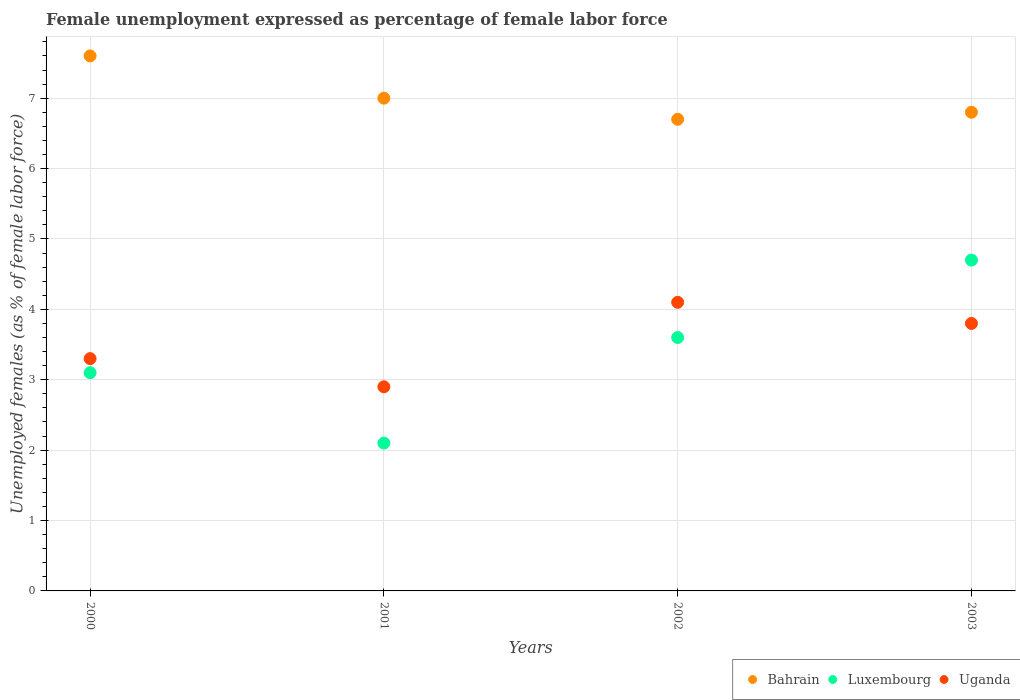Is the number of dotlines equal to the number of legend labels?
Your response must be concise. Yes. What is the unemployment in females in in Uganda in 2002?
Your response must be concise. 4.1. Across all years, what is the maximum unemployment in females in in Bahrain?
Make the answer very short. 7.6. Across all years, what is the minimum unemployment in females in in Bahrain?
Your answer should be very brief. 6.7. In which year was the unemployment in females in in Bahrain minimum?
Provide a succinct answer. 2002. What is the total unemployment in females in in Bahrain in the graph?
Give a very brief answer. 28.1. What is the difference between the unemployment in females in in Bahrain in 2000 and that in 2001?
Make the answer very short. 0.6. What is the difference between the unemployment in females in in Bahrain in 2003 and the unemployment in females in in Luxembourg in 2001?
Your answer should be very brief. 4.7. What is the average unemployment in females in in Bahrain per year?
Make the answer very short. 7.02. In the year 2000, what is the difference between the unemployment in females in in Bahrain and unemployment in females in in Uganda?
Provide a short and direct response. 4.3. In how many years, is the unemployment in females in in Bahrain greater than 0.6000000000000001 %?
Provide a short and direct response. 4. What is the ratio of the unemployment in females in in Bahrain in 2000 to that in 2003?
Your response must be concise. 1.12. Is the unemployment in females in in Bahrain in 2000 less than that in 2002?
Offer a terse response. No. What is the difference between the highest and the second highest unemployment in females in in Bahrain?
Your answer should be very brief. 0.6. What is the difference between the highest and the lowest unemployment in females in in Luxembourg?
Your response must be concise. 2.6. In how many years, is the unemployment in females in in Uganda greater than the average unemployment in females in in Uganda taken over all years?
Your response must be concise. 2. Is the sum of the unemployment in females in in Luxembourg in 2000 and 2001 greater than the maximum unemployment in females in in Bahrain across all years?
Your response must be concise. No. Is it the case that in every year, the sum of the unemployment in females in in Uganda and unemployment in females in in Luxembourg  is greater than the unemployment in females in in Bahrain?
Your answer should be very brief. No. Does the unemployment in females in in Luxembourg monotonically increase over the years?
Offer a very short reply. No. Is the unemployment in females in in Bahrain strictly greater than the unemployment in females in in Uganda over the years?
Make the answer very short. Yes. Is the unemployment in females in in Uganda strictly less than the unemployment in females in in Luxembourg over the years?
Your response must be concise. No. How many dotlines are there?
Provide a succinct answer. 3. What is the difference between two consecutive major ticks on the Y-axis?
Your answer should be very brief. 1. Does the graph contain any zero values?
Your answer should be compact. No. Does the graph contain grids?
Give a very brief answer. Yes. Where does the legend appear in the graph?
Keep it short and to the point. Bottom right. How many legend labels are there?
Your answer should be very brief. 3. What is the title of the graph?
Offer a very short reply. Female unemployment expressed as percentage of female labor force. What is the label or title of the X-axis?
Provide a short and direct response. Years. What is the label or title of the Y-axis?
Offer a very short reply. Unemployed females (as % of female labor force). What is the Unemployed females (as % of female labor force) in Bahrain in 2000?
Keep it short and to the point. 7.6. What is the Unemployed females (as % of female labor force) in Luxembourg in 2000?
Offer a terse response. 3.1. What is the Unemployed females (as % of female labor force) of Uganda in 2000?
Your response must be concise. 3.3. What is the Unemployed females (as % of female labor force) in Luxembourg in 2001?
Provide a short and direct response. 2.1. What is the Unemployed females (as % of female labor force) of Uganda in 2001?
Keep it short and to the point. 2.9. What is the Unemployed females (as % of female labor force) in Bahrain in 2002?
Your answer should be compact. 6.7. What is the Unemployed females (as % of female labor force) in Luxembourg in 2002?
Keep it short and to the point. 3.6. What is the Unemployed females (as % of female labor force) of Uganda in 2002?
Provide a short and direct response. 4.1. What is the Unemployed females (as % of female labor force) of Bahrain in 2003?
Your response must be concise. 6.8. What is the Unemployed females (as % of female labor force) in Luxembourg in 2003?
Offer a terse response. 4.7. What is the Unemployed females (as % of female labor force) in Uganda in 2003?
Provide a succinct answer. 3.8. Across all years, what is the maximum Unemployed females (as % of female labor force) in Bahrain?
Offer a terse response. 7.6. Across all years, what is the maximum Unemployed females (as % of female labor force) in Luxembourg?
Provide a succinct answer. 4.7. Across all years, what is the maximum Unemployed females (as % of female labor force) in Uganda?
Make the answer very short. 4.1. Across all years, what is the minimum Unemployed females (as % of female labor force) of Bahrain?
Keep it short and to the point. 6.7. Across all years, what is the minimum Unemployed females (as % of female labor force) in Luxembourg?
Keep it short and to the point. 2.1. Across all years, what is the minimum Unemployed females (as % of female labor force) in Uganda?
Offer a terse response. 2.9. What is the total Unemployed females (as % of female labor force) of Bahrain in the graph?
Give a very brief answer. 28.1. What is the difference between the Unemployed females (as % of female labor force) in Bahrain in 2000 and that in 2001?
Your answer should be compact. 0.6. What is the difference between the Unemployed females (as % of female labor force) in Uganda in 2000 and that in 2001?
Provide a succinct answer. 0.4. What is the difference between the Unemployed females (as % of female labor force) in Uganda in 2000 and that in 2002?
Provide a short and direct response. -0.8. What is the difference between the Unemployed females (as % of female labor force) of Luxembourg in 2000 and that in 2003?
Provide a short and direct response. -1.6. What is the difference between the Unemployed females (as % of female labor force) in Uganda in 2000 and that in 2003?
Provide a short and direct response. -0.5. What is the difference between the Unemployed females (as % of female labor force) in Bahrain in 2001 and that in 2002?
Your answer should be very brief. 0.3. What is the difference between the Unemployed females (as % of female labor force) in Luxembourg in 2001 and that in 2003?
Offer a very short reply. -2.6. What is the difference between the Unemployed females (as % of female labor force) in Uganda in 2001 and that in 2003?
Your answer should be very brief. -0.9. What is the difference between the Unemployed females (as % of female labor force) in Bahrain in 2002 and that in 2003?
Ensure brevity in your answer.  -0.1. What is the difference between the Unemployed females (as % of female labor force) in Luxembourg in 2002 and that in 2003?
Offer a very short reply. -1.1. What is the difference between the Unemployed females (as % of female labor force) in Uganda in 2002 and that in 2003?
Provide a short and direct response. 0.3. What is the difference between the Unemployed females (as % of female labor force) of Bahrain in 2000 and the Unemployed females (as % of female labor force) of Luxembourg in 2001?
Make the answer very short. 5.5. What is the difference between the Unemployed females (as % of female labor force) of Bahrain in 2000 and the Unemployed females (as % of female labor force) of Uganda in 2001?
Provide a succinct answer. 4.7. What is the difference between the Unemployed females (as % of female labor force) in Luxembourg in 2000 and the Unemployed females (as % of female labor force) in Uganda in 2001?
Your answer should be compact. 0.2. What is the difference between the Unemployed females (as % of female labor force) in Bahrain in 2000 and the Unemployed females (as % of female labor force) in Luxembourg in 2002?
Ensure brevity in your answer.  4. What is the difference between the Unemployed females (as % of female labor force) in Luxembourg in 2000 and the Unemployed females (as % of female labor force) in Uganda in 2002?
Make the answer very short. -1. What is the difference between the Unemployed females (as % of female labor force) in Bahrain in 2000 and the Unemployed females (as % of female labor force) in Uganda in 2003?
Keep it short and to the point. 3.8. What is the difference between the Unemployed females (as % of female labor force) of Luxembourg in 2000 and the Unemployed females (as % of female labor force) of Uganda in 2003?
Make the answer very short. -0.7. What is the difference between the Unemployed females (as % of female labor force) of Luxembourg in 2001 and the Unemployed females (as % of female labor force) of Uganda in 2002?
Make the answer very short. -2. What is the difference between the Unemployed females (as % of female labor force) of Luxembourg in 2001 and the Unemployed females (as % of female labor force) of Uganda in 2003?
Your answer should be very brief. -1.7. What is the difference between the Unemployed females (as % of female labor force) of Luxembourg in 2002 and the Unemployed females (as % of female labor force) of Uganda in 2003?
Your answer should be compact. -0.2. What is the average Unemployed females (as % of female labor force) in Bahrain per year?
Provide a succinct answer. 7.03. What is the average Unemployed females (as % of female labor force) in Luxembourg per year?
Your answer should be compact. 3.38. What is the average Unemployed females (as % of female labor force) in Uganda per year?
Provide a short and direct response. 3.52. In the year 2000, what is the difference between the Unemployed females (as % of female labor force) of Bahrain and Unemployed females (as % of female labor force) of Luxembourg?
Keep it short and to the point. 4.5. In the year 2000, what is the difference between the Unemployed females (as % of female labor force) in Bahrain and Unemployed females (as % of female labor force) in Uganda?
Give a very brief answer. 4.3. In the year 2001, what is the difference between the Unemployed females (as % of female labor force) of Bahrain and Unemployed females (as % of female labor force) of Uganda?
Your response must be concise. 4.1. In the year 2002, what is the difference between the Unemployed females (as % of female labor force) in Bahrain and Unemployed females (as % of female labor force) in Luxembourg?
Offer a very short reply. 3.1. In the year 2002, what is the difference between the Unemployed females (as % of female labor force) in Bahrain and Unemployed females (as % of female labor force) in Uganda?
Offer a terse response. 2.6. In the year 2002, what is the difference between the Unemployed females (as % of female labor force) of Luxembourg and Unemployed females (as % of female labor force) of Uganda?
Provide a short and direct response. -0.5. In the year 2003, what is the difference between the Unemployed females (as % of female labor force) of Bahrain and Unemployed females (as % of female labor force) of Luxembourg?
Offer a terse response. 2.1. In the year 2003, what is the difference between the Unemployed females (as % of female labor force) of Bahrain and Unemployed females (as % of female labor force) of Uganda?
Keep it short and to the point. 3. What is the ratio of the Unemployed females (as % of female labor force) in Bahrain in 2000 to that in 2001?
Your answer should be very brief. 1.09. What is the ratio of the Unemployed females (as % of female labor force) of Luxembourg in 2000 to that in 2001?
Your answer should be compact. 1.48. What is the ratio of the Unemployed females (as % of female labor force) of Uganda in 2000 to that in 2001?
Provide a short and direct response. 1.14. What is the ratio of the Unemployed females (as % of female labor force) of Bahrain in 2000 to that in 2002?
Provide a succinct answer. 1.13. What is the ratio of the Unemployed females (as % of female labor force) of Luxembourg in 2000 to that in 2002?
Your answer should be compact. 0.86. What is the ratio of the Unemployed females (as % of female labor force) of Uganda in 2000 to that in 2002?
Provide a short and direct response. 0.8. What is the ratio of the Unemployed females (as % of female labor force) of Bahrain in 2000 to that in 2003?
Provide a short and direct response. 1.12. What is the ratio of the Unemployed females (as % of female labor force) of Luxembourg in 2000 to that in 2003?
Ensure brevity in your answer.  0.66. What is the ratio of the Unemployed females (as % of female labor force) of Uganda in 2000 to that in 2003?
Offer a terse response. 0.87. What is the ratio of the Unemployed females (as % of female labor force) in Bahrain in 2001 to that in 2002?
Your response must be concise. 1.04. What is the ratio of the Unemployed females (as % of female labor force) of Luxembourg in 2001 to that in 2002?
Make the answer very short. 0.58. What is the ratio of the Unemployed females (as % of female labor force) in Uganda in 2001 to that in 2002?
Ensure brevity in your answer.  0.71. What is the ratio of the Unemployed females (as % of female labor force) in Bahrain in 2001 to that in 2003?
Give a very brief answer. 1.03. What is the ratio of the Unemployed females (as % of female labor force) of Luxembourg in 2001 to that in 2003?
Ensure brevity in your answer.  0.45. What is the ratio of the Unemployed females (as % of female labor force) in Uganda in 2001 to that in 2003?
Your answer should be compact. 0.76. What is the ratio of the Unemployed females (as % of female labor force) in Luxembourg in 2002 to that in 2003?
Keep it short and to the point. 0.77. What is the ratio of the Unemployed females (as % of female labor force) of Uganda in 2002 to that in 2003?
Give a very brief answer. 1.08. What is the difference between the highest and the second highest Unemployed females (as % of female labor force) in Bahrain?
Give a very brief answer. 0.6. What is the difference between the highest and the second highest Unemployed females (as % of female labor force) of Uganda?
Provide a short and direct response. 0.3. What is the difference between the highest and the lowest Unemployed females (as % of female labor force) of Luxembourg?
Make the answer very short. 2.6. 